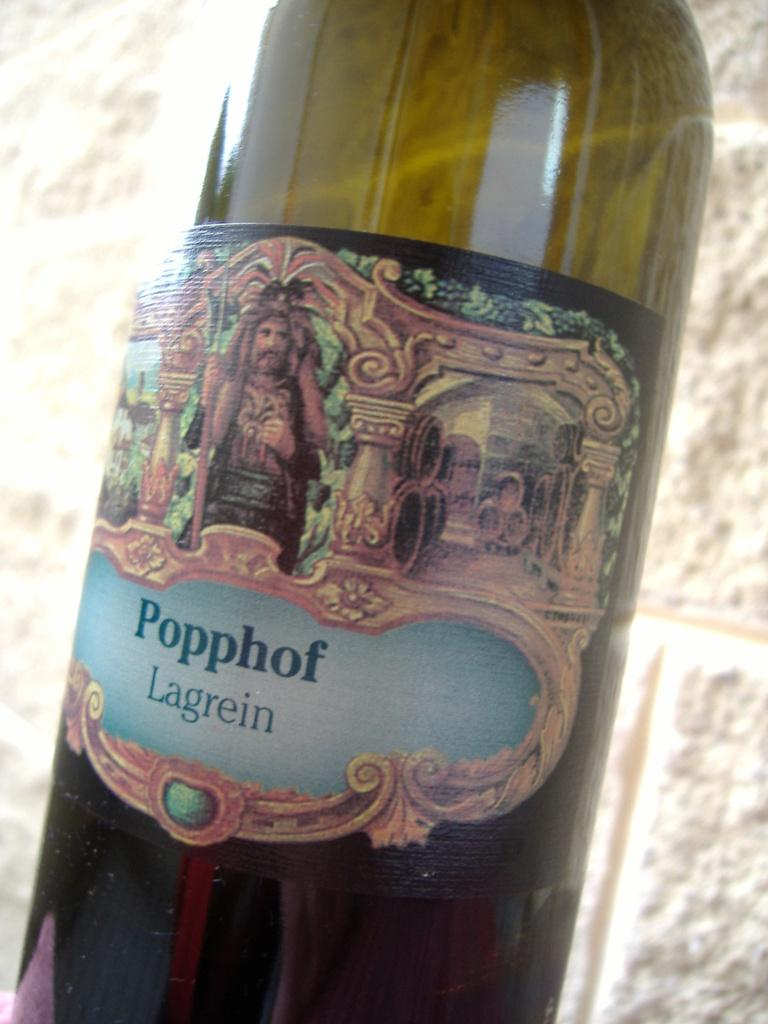What can be seen in the image? There is a bottle in the image. Can you describe the bottle? The bottle is labelled as "poppof lagerain" and features an image of a man on the label. What is visible in the background of the image? There is a brick wall in the background of the image. How many trees are visible in the image? There are no trees visible in the image; it features a bottle with a label and a brick wall in the background. 